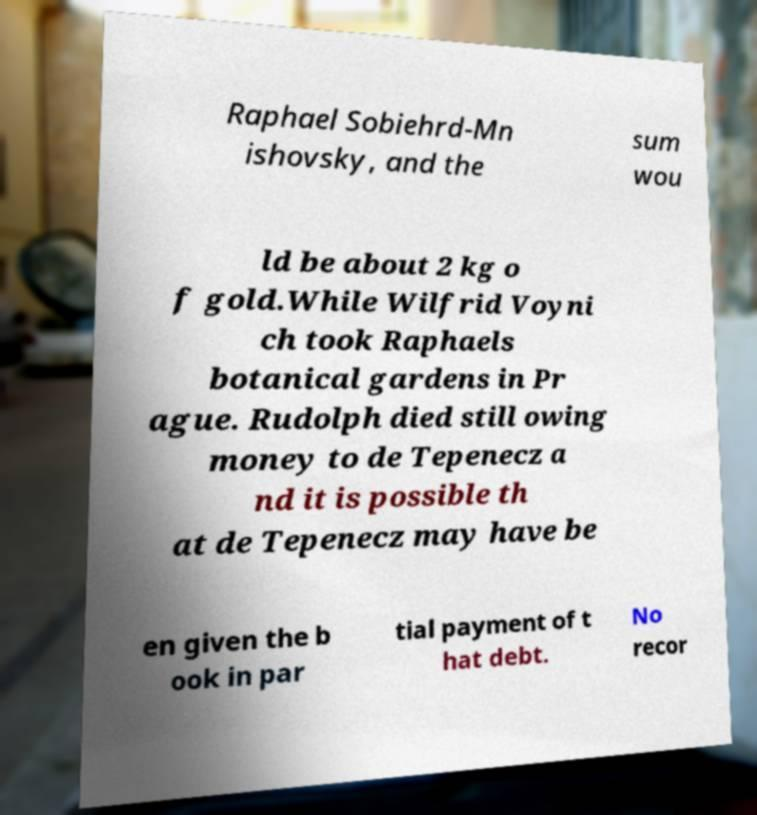Please read and relay the text visible in this image. What does it say? Raphael Sobiehrd-Mn ishovsky, and the sum wou ld be about 2 kg o f gold.While Wilfrid Voyni ch took Raphaels botanical gardens in Pr ague. Rudolph died still owing money to de Tepenecz a nd it is possible th at de Tepenecz may have be en given the b ook in par tial payment of t hat debt. No recor 